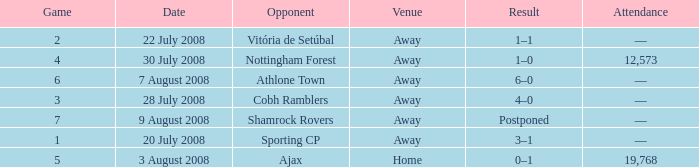What is the lowest game number on 20 July 2008? 1.0. 